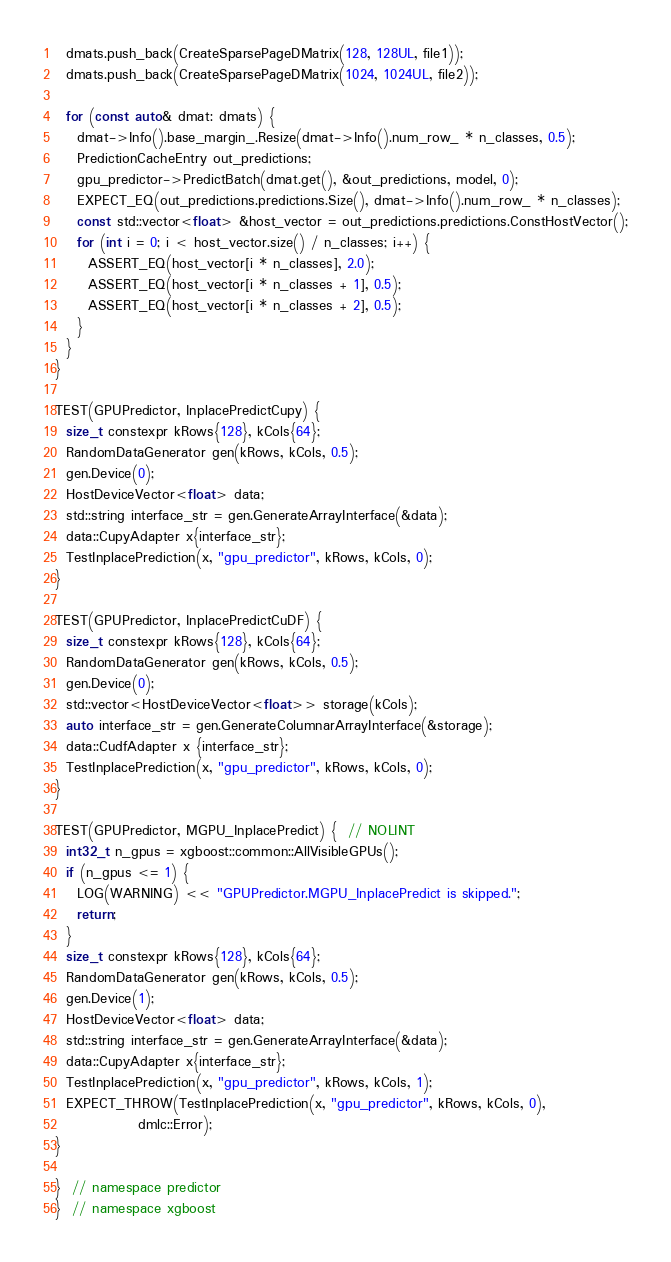Convert code to text. <code><loc_0><loc_0><loc_500><loc_500><_Cuda_>  dmats.push_back(CreateSparsePageDMatrix(128, 128UL, file1));
  dmats.push_back(CreateSparsePageDMatrix(1024, 1024UL, file2));

  for (const auto& dmat: dmats) {
    dmat->Info().base_margin_.Resize(dmat->Info().num_row_ * n_classes, 0.5);
    PredictionCacheEntry out_predictions;
    gpu_predictor->PredictBatch(dmat.get(), &out_predictions, model, 0);
    EXPECT_EQ(out_predictions.predictions.Size(), dmat->Info().num_row_ * n_classes);
    const std::vector<float> &host_vector = out_predictions.predictions.ConstHostVector();
    for (int i = 0; i < host_vector.size() / n_classes; i++) {
      ASSERT_EQ(host_vector[i * n_classes], 2.0);
      ASSERT_EQ(host_vector[i * n_classes + 1], 0.5);
      ASSERT_EQ(host_vector[i * n_classes + 2], 0.5);
    }
  }
}

TEST(GPUPredictor, InplacePredictCupy) {
  size_t constexpr kRows{128}, kCols{64};
  RandomDataGenerator gen(kRows, kCols, 0.5);
  gen.Device(0);
  HostDeviceVector<float> data;
  std::string interface_str = gen.GenerateArrayInterface(&data);
  data::CupyAdapter x{interface_str};
  TestInplacePrediction(x, "gpu_predictor", kRows, kCols, 0);
}

TEST(GPUPredictor, InplacePredictCuDF) {
  size_t constexpr kRows{128}, kCols{64};
  RandomDataGenerator gen(kRows, kCols, 0.5);
  gen.Device(0);
  std::vector<HostDeviceVector<float>> storage(kCols);
  auto interface_str = gen.GenerateColumnarArrayInterface(&storage);
  data::CudfAdapter x {interface_str};
  TestInplacePrediction(x, "gpu_predictor", kRows, kCols, 0);
}

TEST(GPUPredictor, MGPU_InplacePredict) {  // NOLINT
  int32_t n_gpus = xgboost::common::AllVisibleGPUs();
  if (n_gpus <= 1) {
    LOG(WARNING) << "GPUPredictor.MGPU_InplacePredict is skipped.";
    return;
  }
  size_t constexpr kRows{128}, kCols{64};
  RandomDataGenerator gen(kRows, kCols, 0.5);
  gen.Device(1);
  HostDeviceVector<float> data;
  std::string interface_str = gen.GenerateArrayInterface(&data);
  data::CupyAdapter x{interface_str};
  TestInplacePrediction(x, "gpu_predictor", kRows, kCols, 1);
  EXPECT_THROW(TestInplacePrediction(x, "gpu_predictor", kRows, kCols, 0),
               dmlc::Error);
}

}  // namespace predictor
}  // namespace xgboost
</code> 